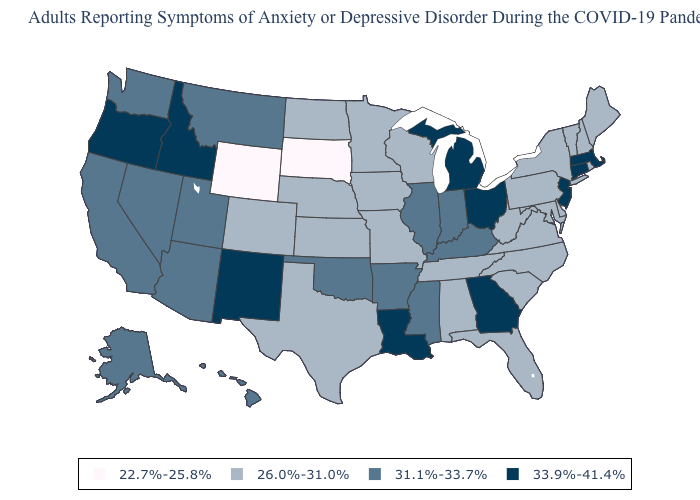Name the states that have a value in the range 31.1%-33.7%?
Quick response, please. Alaska, Arizona, Arkansas, California, Hawaii, Illinois, Indiana, Kentucky, Mississippi, Montana, Nevada, Oklahoma, Utah, Washington. Name the states that have a value in the range 26.0%-31.0%?
Keep it brief. Alabama, Colorado, Delaware, Florida, Iowa, Kansas, Maine, Maryland, Minnesota, Missouri, Nebraska, New Hampshire, New York, North Carolina, North Dakota, Pennsylvania, Rhode Island, South Carolina, Tennessee, Texas, Vermont, Virginia, West Virginia, Wisconsin. What is the value of Alaska?
Be succinct. 31.1%-33.7%. Does the map have missing data?
Write a very short answer. No. Name the states that have a value in the range 33.9%-41.4%?
Concise answer only. Connecticut, Georgia, Idaho, Louisiana, Massachusetts, Michigan, New Jersey, New Mexico, Ohio, Oregon. Which states have the lowest value in the MidWest?
Quick response, please. South Dakota. Does the map have missing data?
Keep it brief. No. Does Nebraska have the lowest value in the MidWest?
Quick response, please. No. Is the legend a continuous bar?
Keep it brief. No. Does Kansas have the lowest value in the MidWest?
Answer briefly. No. Among the states that border Alabama , does Mississippi have the lowest value?
Be succinct. No. Does New Hampshire have the lowest value in the USA?
Short answer required. No. Name the states that have a value in the range 22.7%-25.8%?
Concise answer only. South Dakota, Wyoming. Among the states that border Delaware , does Maryland have the highest value?
Be succinct. No. 